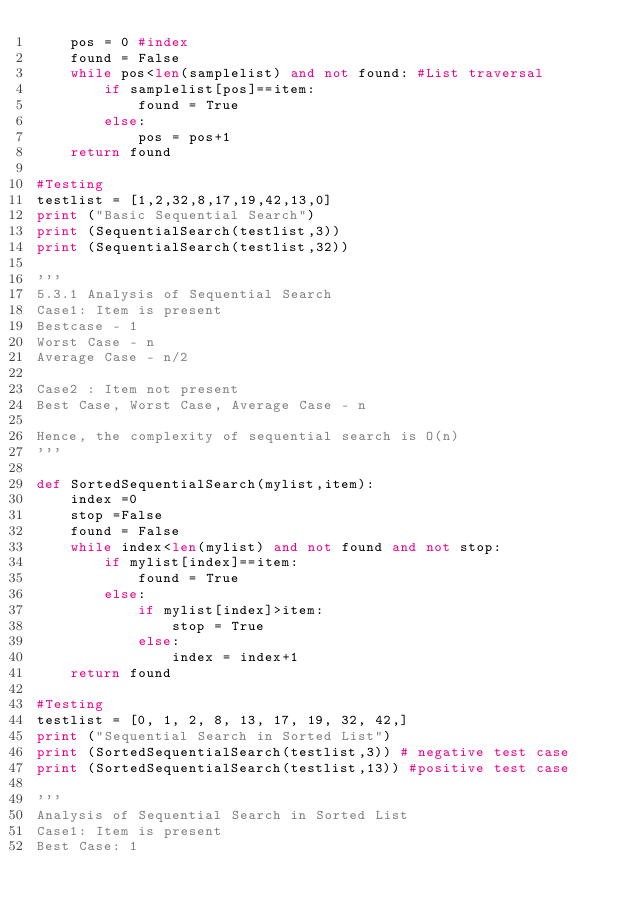Convert code to text. <code><loc_0><loc_0><loc_500><loc_500><_Python_>    pos = 0 #index
    found = False
    while pos<len(samplelist) and not found: #List traversal
        if samplelist[pos]==item:
            found = True
        else:
            pos = pos+1
    return found

#Testing
testlist = [1,2,32,8,17,19,42,13,0]
print ("Basic Sequential Search")
print (SequentialSearch(testlist,3))
print (SequentialSearch(testlist,32))

'''
5.3.1 Analysis of Sequential Search
Case1: Item is present
Bestcase - 1
Worst Case - n
Average Case - n/2

Case2 : Item not present
Best Case, Worst Case, Average Case - n

Hence, the complexity of sequential search is O(n)
'''

def SortedSequentialSearch(mylist,item):
    index =0
    stop =False
    found = False
    while index<len(mylist) and not found and not stop:
        if mylist[index]==item:
            found = True
        else:
            if mylist[index]>item:
                stop = True
            else:
                index = index+1
    return found

#Testing
testlist = [0, 1, 2, 8, 13, 17, 19, 32, 42,]
print ("Sequential Search in Sorted List")
print (SortedSequentialSearch(testlist,3)) # negative test case
print (SortedSequentialSearch(testlist,13)) #positive test case

'''
Analysis of Sequential Search in Sorted List
Case1: Item is present
Best Case: 1</code> 